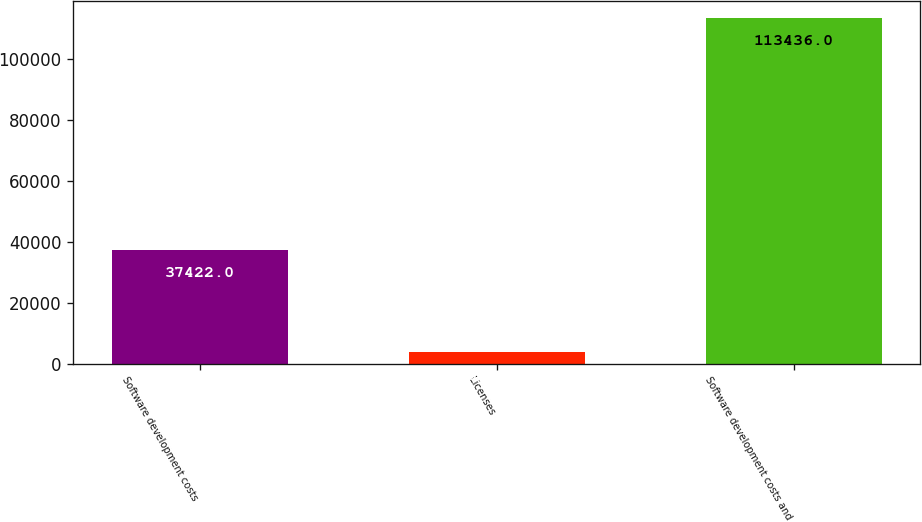Convert chart to OTSL. <chart><loc_0><loc_0><loc_500><loc_500><bar_chart><fcel>Software development costs<fcel>Licenses<fcel>Software development costs and<nl><fcel>37422<fcel>3633<fcel>113436<nl></chart> 